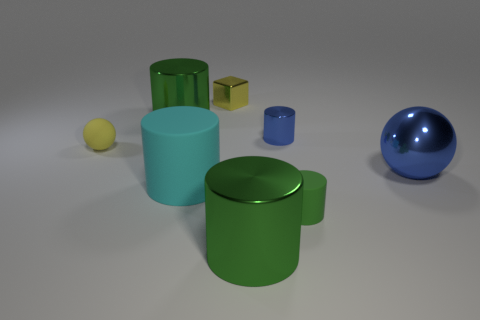Subtract all green balls. How many green cylinders are left? 3 Subtract all blue cylinders. How many cylinders are left? 4 Subtract all small metallic cylinders. How many cylinders are left? 4 Subtract all red cylinders. Subtract all yellow balls. How many cylinders are left? 5 Add 1 matte cylinders. How many objects exist? 9 Subtract all cylinders. How many objects are left? 3 Add 5 yellow spheres. How many yellow spheres are left? 6 Add 8 large spheres. How many large spheres exist? 9 Subtract 0 gray spheres. How many objects are left? 8 Subtract all small cyan objects. Subtract all cylinders. How many objects are left? 3 